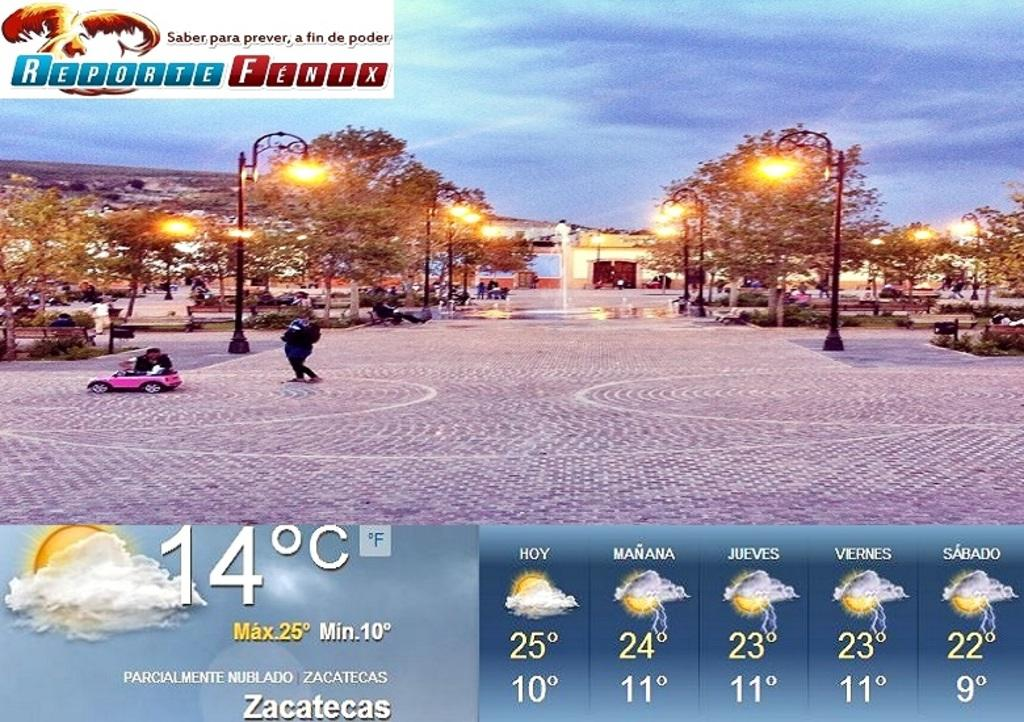Provide a one-sentence caption for the provided image. Reporte fenx showing the weather for the entire week. 